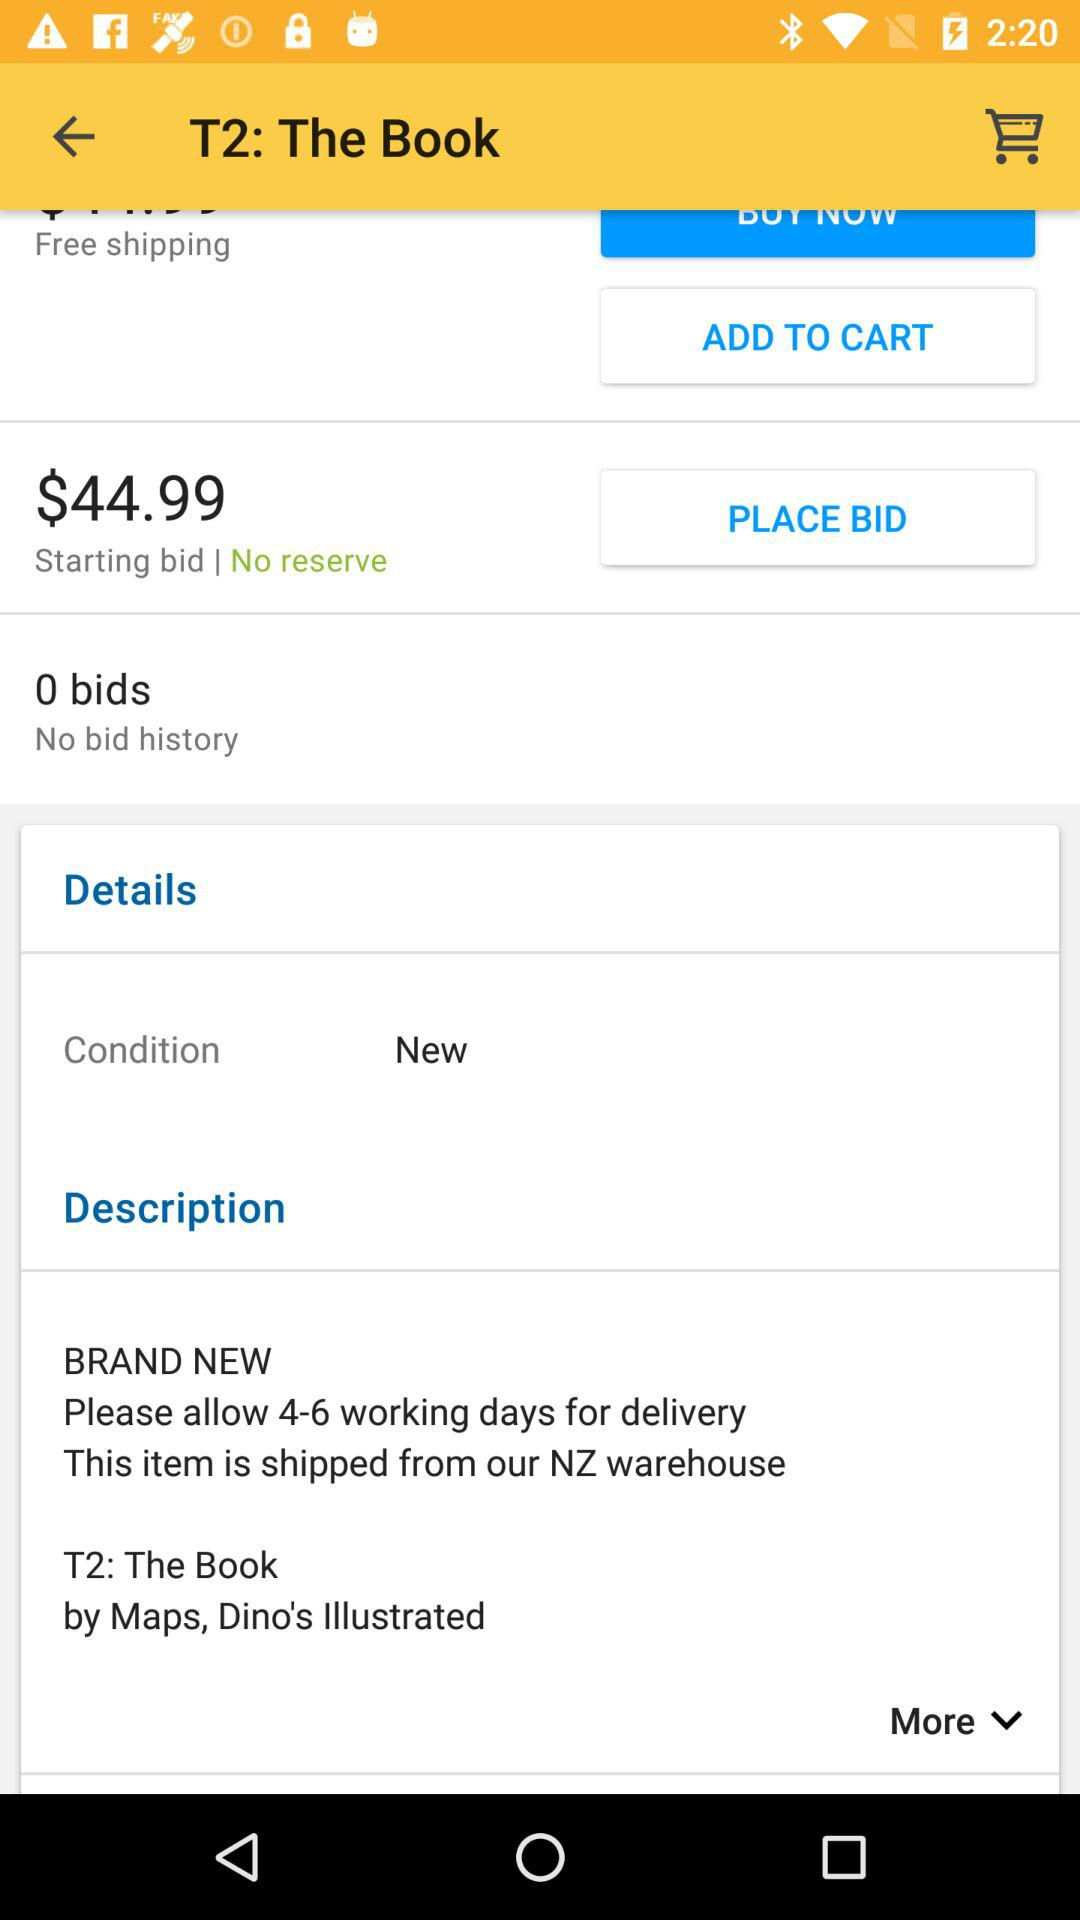How many bids are there? There are 0 bids. 